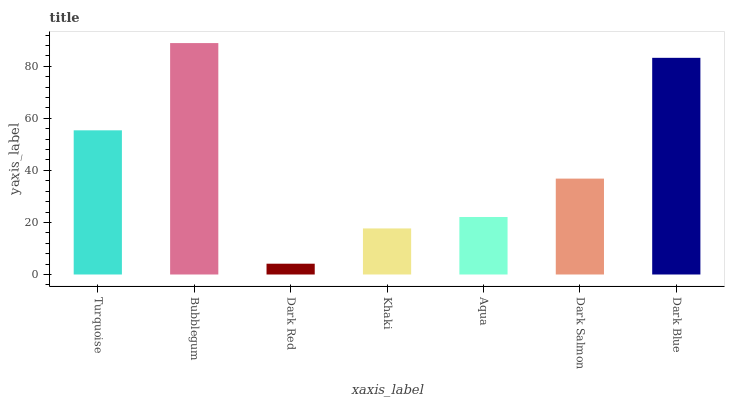Is Dark Red the minimum?
Answer yes or no. Yes. Is Bubblegum the maximum?
Answer yes or no. Yes. Is Bubblegum the minimum?
Answer yes or no. No. Is Dark Red the maximum?
Answer yes or no. No. Is Bubblegum greater than Dark Red?
Answer yes or no. Yes. Is Dark Red less than Bubblegum?
Answer yes or no. Yes. Is Dark Red greater than Bubblegum?
Answer yes or no. No. Is Bubblegum less than Dark Red?
Answer yes or no. No. Is Dark Salmon the high median?
Answer yes or no. Yes. Is Dark Salmon the low median?
Answer yes or no. Yes. Is Turquoise the high median?
Answer yes or no. No. Is Aqua the low median?
Answer yes or no. No. 